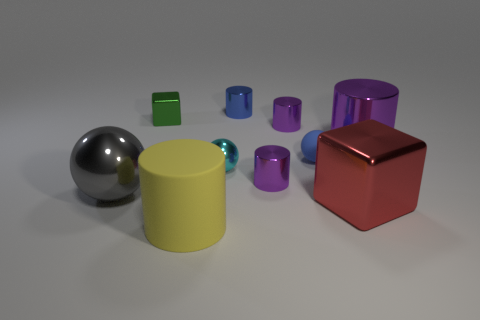Are there the same number of big purple objects that are in front of the yellow rubber cylinder and green things that are left of the small blue metal thing?
Ensure brevity in your answer.  No. Are there any tiny cylinders in front of the small blue object that is behind the small green thing?
Your response must be concise. Yes. What is the shape of the cyan object that is made of the same material as the gray thing?
Give a very brief answer. Sphere. Is there any other thing that is the same color as the big metallic sphere?
Make the answer very short. No. What material is the tiny blue object that is in front of the tiny thing that is left of the large yellow matte cylinder made of?
Your response must be concise. Rubber. Is there a red shiny object of the same shape as the small cyan metallic object?
Your answer should be very brief. No. How many other objects are the same shape as the large purple metallic object?
Offer a terse response. 4. There is a big thing that is behind the matte cylinder and on the left side of the small shiny sphere; what is its shape?
Your response must be concise. Sphere. What size is the sphere behind the cyan sphere?
Offer a very short reply. Small. Do the green shiny thing and the red object have the same size?
Offer a terse response. No. 